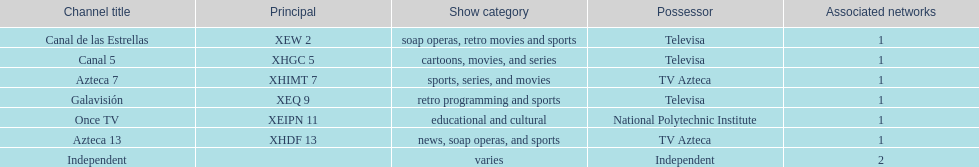What is the only network owned by national polytechnic institute? Once TV. 